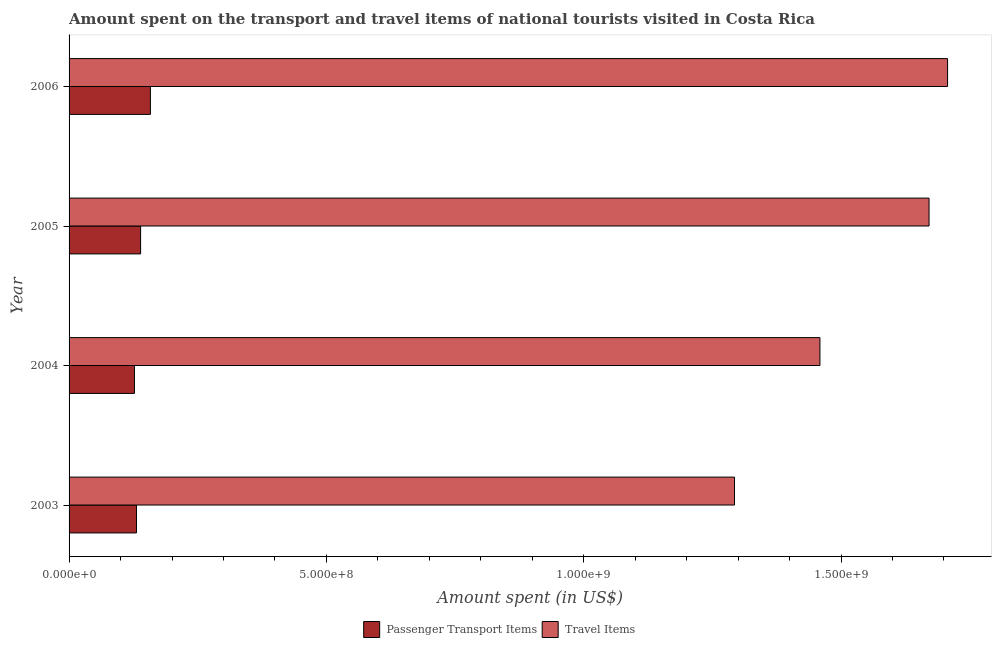How many groups of bars are there?
Your answer should be compact. 4. Are the number of bars on each tick of the Y-axis equal?
Your answer should be compact. Yes. What is the amount spent on passenger transport items in 2006?
Offer a terse response. 1.58e+08. Across all years, what is the maximum amount spent on passenger transport items?
Your answer should be very brief. 1.58e+08. Across all years, what is the minimum amount spent on passenger transport items?
Give a very brief answer. 1.27e+08. In which year was the amount spent in travel items maximum?
Keep it short and to the point. 2006. In which year was the amount spent in travel items minimum?
Give a very brief answer. 2003. What is the total amount spent in travel items in the graph?
Make the answer very short. 6.13e+09. What is the difference between the amount spent on passenger transport items in 2004 and that in 2006?
Your answer should be very brief. -3.10e+07. What is the difference between the amount spent on passenger transport items in 2003 and the amount spent in travel items in 2006?
Provide a succinct answer. -1.58e+09. What is the average amount spent on passenger transport items per year?
Offer a terse response. 1.39e+08. In the year 2003, what is the difference between the amount spent in travel items and amount spent on passenger transport items?
Provide a succinct answer. 1.16e+09. In how many years, is the amount spent on passenger transport items greater than 300000000 US$?
Offer a terse response. 0. Is the amount spent in travel items in 2004 less than that in 2006?
Provide a short and direct response. Yes. Is the difference between the amount spent in travel items in 2004 and 2005 greater than the difference between the amount spent on passenger transport items in 2004 and 2005?
Offer a very short reply. No. What is the difference between the highest and the second highest amount spent on passenger transport items?
Provide a short and direct response. 1.90e+07. What is the difference between the highest and the lowest amount spent on passenger transport items?
Give a very brief answer. 3.10e+07. What does the 2nd bar from the top in 2004 represents?
Provide a succinct answer. Passenger Transport Items. What does the 2nd bar from the bottom in 2003 represents?
Give a very brief answer. Travel Items. Are all the bars in the graph horizontal?
Your answer should be very brief. Yes. What is the difference between two consecutive major ticks on the X-axis?
Keep it short and to the point. 5.00e+08. Does the graph contain any zero values?
Your response must be concise. No. Does the graph contain grids?
Give a very brief answer. No. Where does the legend appear in the graph?
Offer a very short reply. Bottom center. How are the legend labels stacked?
Offer a terse response. Horizontal. What is the title of the graph?
Ensure brevity in your answer.  Amount spent on the transport and travel items of national tourists visited in Costa Rica. What is the label or title of the X-axis?
Offer a terse response. Amount spent (in US$). What is the label or title of the Y-axis?
Give a very brief answer. Year. What is the Amount spent (in US$) of Passenger Transport Items in 2003?
Provide a succinct answer. 1.31e+08. What is the Amount spent (in US$) in Travel Items in 2003?
Your response must be concise. 1.29e+09. What is the Amount spent (in US$) of Passenger Transport Items in 2004?
Make the answer very short. 1.27e+08. What is the Amount spent (in US$) in Travel Items in 2004?
Give a very brief answer. 1.46e+09. What is the Amount spent (in US$) in Passenger Transport Items in 2005?
Make the answer very short. 1.39e+08. What is the Amount spent (in US$) of Travel Items in 2005?
Provide a succinct answer. 1.67e+09. What is the Amount spent (in US$) of Passenger Transport Items in 2006?
Your answer should be compact. 1.58e+08. What is the Amount spent (in US$) in Travel Items in 2006?
Provide a succinct answer. 1.71e+09. Across all years, what is the maximum Amount spent (in US$) of Passenger Transport Items?
Give a very brief answer. 1.58e+08. Across all years, what is the maximum Amount spent (in US$) in Travel Items?
Your response must be concise. 1.71e+09. Across all years, what is the minimum Amount spent (in US$) of Passenger Transport Items?
Give a very brief answer. 1.27e+08. Across all years, what is the minimum Amount spent (in US$) of Travel Items?
Ensure brevity in your answer.  1.29e+09. What is the total Amount spent (in US$) in Passenger Transport Items in the graph?
Offer a very short reply. 5.55e+08. What is the total Amount spent (in US$) of Travel Items in the graph?
Ensure brevity in your answer.  6.13e+09. What is the difference between the Amount spent (in US$) in Passenger Transport Items in 2003 and that in 2004?
Ensure brevity in your answer.  4.00e+06. What is the difference between the Amount spent (in US$) in Travel Items in 2003 and that in 2004?
Your answer should be very brief. -1.66e+08. What is the difference between the Amount spent (in US$) of Passenger Transport Items in 2003 and that in 2005?
Provide a short and direct response. -8.00e+06. What is the difference between the Amount spent (in US$) of Travel Items in 2003 and that in 2005?
Offer a very short reply. -3.78e+08. What is the difference between the Amount spent (in US$) of Passenger Transport Items in 2003 and that in 2006?
Your answer should be very brief. -2.70e+07. What is the difference between the Amount spent (in US$) of Travel Items in 2003 and that in 2006?
Your answer should be very brief. -4.14e+08. What is the difference between the Amount spent (in US$) in Passenger Transport Items in 2004 and that in 2005?
Provide a short and direct response. -1.20e+07. What is the difference between the Amount spent (in US$) of Travel Items in 2004 and that in 2005?
Keep it short and to the point. -2.12e+08. What is the difference between the Amount spent (in US$) in Passenger Transport Items in 2004 and that in 2006?
Your response must be concise. -3.10e+07. What is the difference between the Amount spent (in US$) of Travel Items in 2004 and that in 2006?
Provide a short and direct response. -2.48e+08. What is the difference between the Amount spent (in US$) in Passenger Transport Items in 2005 and that in 2006?
Offer a terse response. -1.90e+07. What is the difference between the Amount spent (in US$) of Travel Items in 2005 and that in 2006?
Keep it short and to the point. -3.60e+07. What is the difference between the Amount spent (in US$) of Passenger Transport Items in 2003 and the Amount spent (in US$) of Travel Items in 2004?
Give a very brief answer. -1.33e+09. What is the difference between the Amount spent (in US$) in Passenger Transport Items in 2003 and the Amount spent (in US$) in Travel Items in 2005?
Keep it short and to the point. -1.54e+09. What is the difference between the Amount spent (in US$) of Passenger Transport Items in 2003 and the Amount spent (in US$) of Travel Items in 2006?
Give a very brief answer. -1.58e+09. What is the difference between the Amount spent (in US$) of Passenger Transport Items in 2004 and the Amount spent (in US$) of Travel Items in 2005?
Offer a terse response. -1.54e+09. What is the difference between the Amount spent (in US$) of Passenger Transport Items in 2004 and the Amount spent (in US$) of Travel Items in 2006?
Make the answer very short. -1.58e+09. What is the difference between the Amount spent (in US$) in Passenger Transport Items in 2005 and the Amount spent (in US$) in Travel Items in 2006?
Offer a very short reply. -1.57e+09. What is the average Amount spent (in US$) of Passenger Transport Items per year?
Your answer should be very brief. 1.39e+08. What is the average Amount spent (in US$) of Travel Items per year?
Offer a terse response. 1.53e+09. In the year 2003, what is the difference between the Amount spent (in US$) of Passenger Transport Items and Amount spent (in US$) of Travel Items?
Provide a succinct answer. -1.16e+09. In the year 2004, what is the difference between the Amount spent (in US$) in Passenger Transport Items and Amount spent (in US$) in Travel Items?
Offer a terse response. -1.33e+09. In the year 2005, what is the difference between the Amount spent (in US$) of Passenger Transport Items and Amount spent (in US$) of Travel Items?
Give a very brief answer. -1.53e+09. In the year 2006, what is the difference between the Amount spent (in US$) of Passenger Transport Items and Amount spent (in US$) of Travel Items?
Keep it short and to the point. -1.55e+09. What is the ratio of the Amount spent (in US$) of Passenger Transport Items in 2003 to that in 2004?
Keep it short and to the point. 1.03. What is the ratio of the Amount spent (in US$) in Travel Items in 2003 to that in 2004?
Your response must be concise. 0.89. What is the ratio of the Amount spent (in US$) in Passenger Transport Items in 2003 to that in 2005?
Keep it short and to the point. 0.94. What is the ratio of the Amount spent (in US$) of Travel Items in 2003 to that in 2005?
Keep it short and to the point. 0.77. What is the ratio of the Amount spent (in US$) in Passenger Transport Items in 2003 to that in 2006?
Provide a short and direct response. 0.83. What is the ratio of the Amount spent (in US$) in Travel Items in 2003 to that in 2006?
Offer a terse response. 0.76. What is the ratio of the Amount spent (in US$) of Passenger Transport Items in 2004 to that in 2005?
Offer a very short reply. 0.91. What is the ratio of the Amount spent (in US$) of Travel Items in 2004 to that in 2005?
Ensure brevity in your answer.  0.87. What is the ratio of the Amount spent (in US$) in Passenger Transport Items in 2004 to that in 2006?
Provide a succinct answer. 0.8. What is the ratio of the Amount spent (in US$) in Travel Items in 2004 to that in 2006?
Keep it short and to the point. 0.85. What is the ratio of the Amount spent (in US$) in Passenger Transport Items in 2005 to that in 2006?
Offer a terse response. 0.88. What is the ratio of the Amount spent (in US$) of Travel Items in 2005 to that in 2006?
Your answer should be very brief. 0.98. What is the difference between the highest and the second highest Amount spent (in US$) in Passenger Transport Items?
Give a very brief answer. 1.90e+07. What is the difference between the highest and the second highest Amount spent (in US$) of Travel Items?
Give a very brief answer. 3.60e+07. What is the difference between the highest and the lowest Amount spent (in US$) in Passenger Transport Items?
Keep it short and to the point. 3.10e+07. What is the difference between the highest and the lowest Amount spent (in US$) of Travel Items?
Make the answer very short. 4.14e+08. 